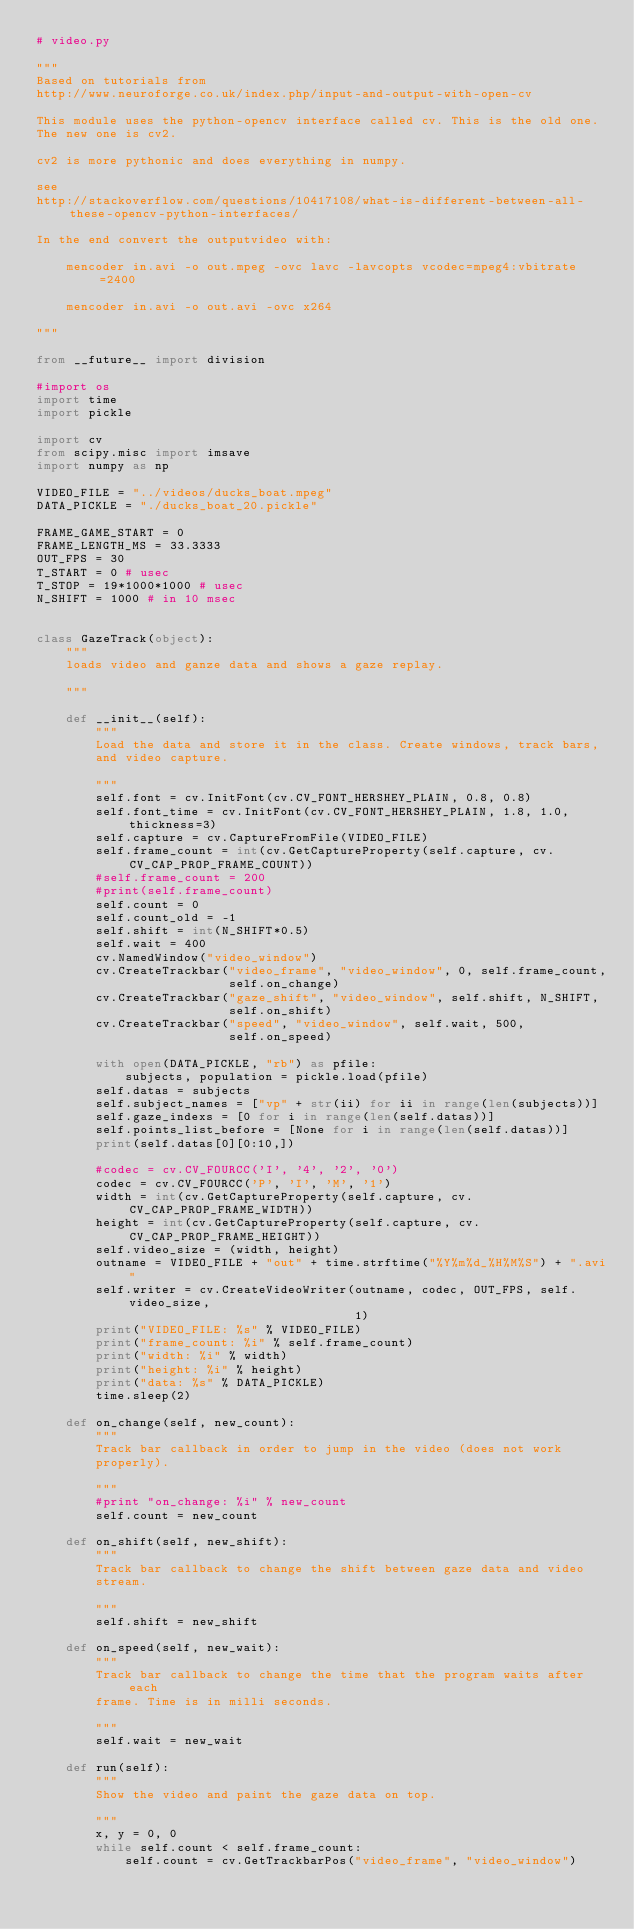Convert code to text. <code><loc_0><loc_0><loc_500><loc_500><_Python_># video.py

"""
Based on tutorials from
http://www.neuroforge.co.uk/index.php/input-and-output-with-open-cv

This module uses the python-opencv interface called cv. This is the old one.
The new one is cv2.

cv2 is more pythonic and does everything in numpy.

see
http://stackoverflow.com/questions/10417108/what-is-different-between-all-these-opencv-python-interfaces/

In the end convert the outputvideo with:

    mencoder in.avi -o out.mpeg -ovc lavc -lavcopts vcodec=mpeg4:vbitrate=2400

    mencoder in.avi -o out.avi -ovc x264

"""

from __future__ import division

#import os
import time
import pickle

import cv
from scipy.misc import imsave
import numpy as np

VIDEO_FILE = "../videos/ducks_boat.mpeg"
DATA_PICKLE = "./ducks_boat_20.pickle"

FRAME_GAME_START = 0
FRAME_LENGTH_MS = 33.3333
OUT_FPS = 30
T_START = 0 # usec
T_STOP = 19*1000*1000 # usec
N_SHIFT = 1000 # in 10 msec


class GazeTrack(object):
    """
    loads video and ganze data and shows a gaze replay.

    """

    def __init__(self):
        """
        Load the data and store it in the class. Create windows, track bars,
        and video capture.

        """
        self.font = cv.InitFont(cv.CV_FONT_HERSHEY_PLAIN, 0.8, 0.8)
        self.font_time = cv.InitFont(cv.CV_FONT_HERSHEY_PLAIN, 1.8, 1.0, thickness=3)
        self.capture = cv.CaptureFromFile(VIDEO_FILE)
        self.frame_count = int(cv.GetCaptureProperty(self.capture, cv.CV_CAP_PROP_FRAME_COUNT))
        #self.frame_count = 200
        #print(self.frame_count)
        self.count = 0
        self.count_old = -1
        self.shift = int(N_SHIFT*0.5)
        self.wait = 400
        cv.NamedWindow("video_window")
        cv.CreateTrackbar("video_frame", "video_window", 0, self.frame_count,
                          self.on_change)
        cv.CreateTrackbar("gaze_shift", "video_window", self.shift, N_SHIFT,
                          self.on_shift)
        cv.CreateTrackbar("speed", "video_window", self.wait, 500,
                          self.on_speed)

        with open(DATA_PICKLE, "rb") as pfile:
            subjects, population = pickle.load(pfile)
        self.datas = subjects
        self.subject_names = ["vp" + str(ii) for ii in range(len(subjects))]
        self.gaze_indexs = [0 for i in range(len(self.datas))]
        self.points_list_before = [None for i in range(len(self.datas))]
        print(self.datas[0][0:10,])

        #codec = cv.CV_FOURCC('I', '4', '2', '0')
        codec = cv.CV_FOURCC('P', 'I', 'M', '1')
        width = int(cv.GetCaptureProperty(self.capture, cv.CV_CAP_PROP_FRAME_WIDTH))
        height = int(cv.GetCaptureProperty(self.capture, cv.CV_CAP_PROP_FRAME_HEIGHT))
        self.video_size = (width, height)
        outname = VIDEO_FILE + "out" + time.strftime("%Y%m%d_%H%M%S") + ".avi"
        self.writer = cv.CreateVideoWriter(outname, codec, OUT_FPS, self.video_size,
                                           1)
        print("VIDEO_FILE: %s" % VIDEO_FILE)
        print("frame_count: %i" % self.frame_count)
        print("width: %i" % width)
        print("height: %i" % height)
        print("data: %s" % DATA_PICKLE)
        time.sleep(2)

    def on_change(self, new_count):
        """
        Track bar callback in order to jump in the video (does not work
        properly).

        """
        #print "on_change: %i" % new_count
        self.count = new_count

    def on_shift(self, new_shift):
        """
        Track bar callback to change the shift between gaze data and video
        stream.

        """
        self.shift = new_shift

    def on_speed(self, new_wait):
        """
        Track bar callback to change the time that the program waits after each
        frame. Time is in milli seconds.

        """
        self.wait = new_wait

    def run(self):
        """
        Show the video and paint the gaze data on top.

        """
        x, y = 0, 0
        while self.count < self.frame_count:
            self.count = cv.GetTrackbarPos("video_frame", "video_window")</code> 